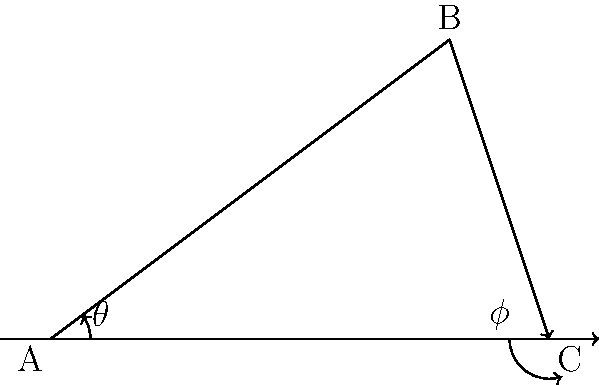In a forensic ballistics investigation, a bullet is fired from point A, reaches its highest point at B, and impacts the ground at point C. The horizontal distance from A to C is 10 meters, and the maximum height of the bullet (at point B) is 6 meters. Using trigonometry, calculate the angle of elevation ($\theta$) at which the bullet was fired and the angle of impact ($\phi$) with the ground. To solve this problem, we'll use trigonometric ratios in right triangles formed by the bullet's trajectory.

Step 1: Calculate the angle of elevation ($\theta$)
- In the right triangle ABD (where D is the point directly below B on the ground):
- $\tan \theta = \frac{\text{opposite}}{\text{adjacent}} = \frac{\text{height}}{\text{half of total horizontal distance}}$
- $\tan \theta = \frac{6}{5} = 1.2$
- $\theta = \arctan(1.2) \approx 50.2°$

Step 2: Calculate the angle of impact ($\phi$)
- In the right triangle BCE (where E is the point directly below B on the ground):
- $\tan \phi = \frac{\text{opposite}}{\text{adjacent}} = \frac{\text{height}}{\text{half of total horizontal distance}}$
- $\tan \phi = \frac{6}{5} = 1.2$
- $\phi = \arctan(1.2) \approx 50.2°$

Note: Due to the symmetry of the parabolic trajectory, the angle of elevation and the angle of impact are equal in this case.

Step 3: Verify using the properties of a parabola
- In a parabolic trajectory, the angle of elevation and angle of impact are equal when the launch and impact points are at the same height.
- This confirms our calculation that $\theta = \phi$.
Answer: $\theta \approx 50.2°$, $\phi \approx 50.2°$ 